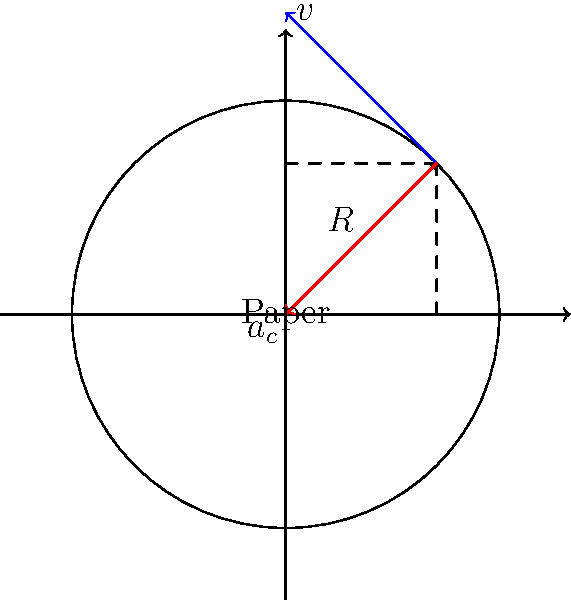In a paper bleaching process, a rotating drum with a radius of 2 meters is used. A small piece of paper with a mass of 0.05 kg is attached to the inner surface of the drum, which rotates at a constant angular velocity of 10 rad/s. Calculate the centripetal force acting on the paper. How would this force potentially impact the paper fibers during the bleaching process? To solve this problem, we'll follow these steps:

1) First, recall the formula for centripetal force:

   $$F_c = m\omega^2r$$

   where $F_c$ is the centripetal force, $m$ is the mass, $\omega$ is the angular velocity, and $r$ is the radius.

2) We're given:
   - Mass (m) = 0.05 kg
   - Angular velocity (ω) = 10 rad/s
   - Radius (r) = 2 m

3) Let's substitute these values into our equation:

   $$F_c = 0.05 \text{ kg} \times (10 \text{ rad/s})^2 \times 2 \text{ m}$$

4) Simplify:
   $$F_c = 0.05 \times 100 \times 2 = 10 \text{ N}$$

5) Therefore, the centripetal force acting on the paper is 10 N.

6) Impact on paper fibers:
   This force could potentially cause stress on the paper fibers, possibly leading to stretching or even tearing if the force is too great. However, it also ensures that the paper remains in contact with the drum surface, which is necessary for even bleaching. The rotation also helps in distributing the bleaching agents evenly across the paper surface.

   As a botanist studying the ecological impact of paper production, you might consider how this mechanical stress during the bleaching process affects the overall quality and lifecycle of the paper product, potentially influencing the demand for raw materials and the environmental footprint of paper production.
Answer: 10 N; may cause fiber stress, ensuring even bleaching distribution 